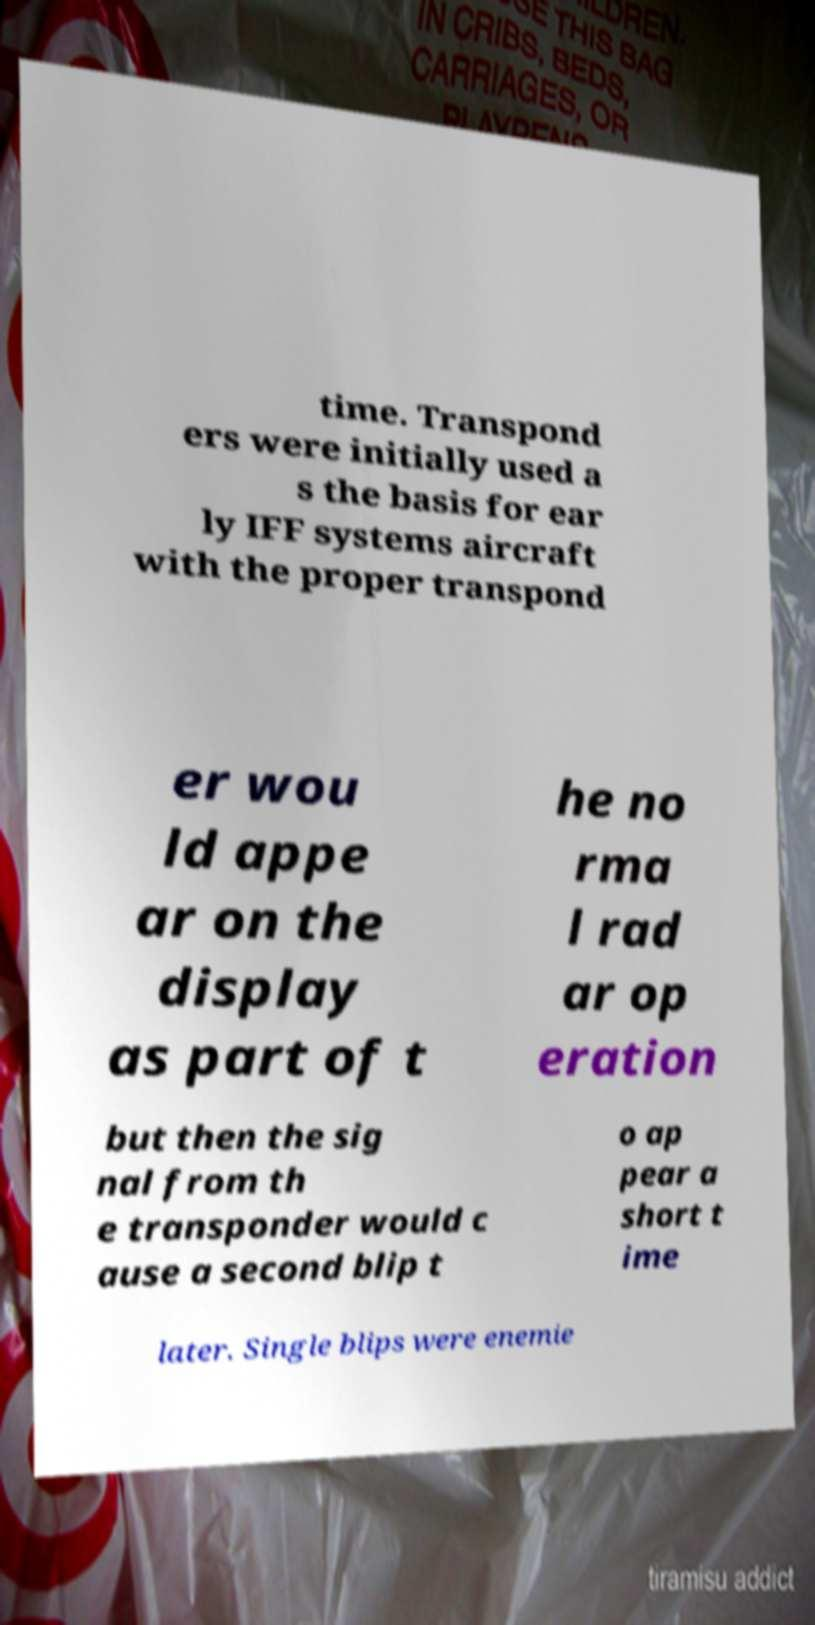What messages or text are displayed in this image? I need them in a readable, typed format. time. Transpond ers were initially used a s the basis for ear ly IFF systems aircraft with the proper transpond er wou ld appe ar on the display as part of t he no rma l rad ar op eration but then the sig nal from th e transponder would c ause a second blip t o ap pear a short t ime later. Single blips were enemie 